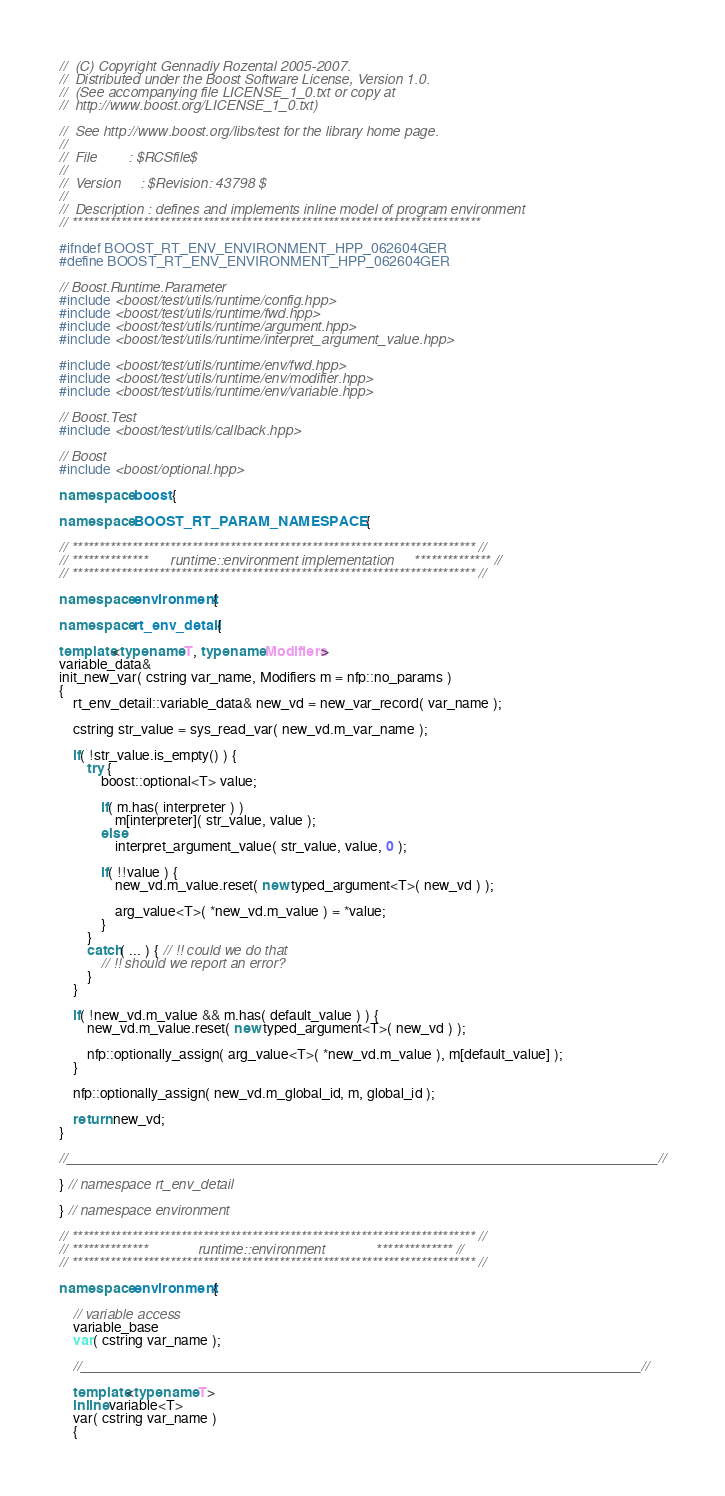<code> <loc_0><loc_0><loc_500><loc_500><_C++_>//  (C) Copyright Gennadiy Rozental 2005-2007.
//  Distributed under the Boost Software License, Version 1.0.
//  (See accompanying file LICENSE_1_0.txt or copy at 
//  http://www.boost.org/LICENSE_1_0.txt)

//  See http://www.boost.org/libs/test for the library home page.
//
//  File        : $RCSfile$
//
//  Version     : $Revision: 43798 $
//
//  Description : defines and implements inline model of program environment 
// ***************************************************************************

#ifndef BOOST_RT_ENV_ENVIRONMENT_HPP_062604GER
#define BOOST_RT_ENV_ENVIRONMENT_HPP_062604GER

// Boost.Runtime.Parameter
#include <boost/test/utils/runtime/config.hpp>
#include <boost/test/utils/runtime/fwd.hpp>
#include <boost/test/utils/runtime/argument.hpp>
#include <boost/test/utils/runtime/interpret_argument_value.hpp>

#include <boost/test/utils/runtime/env/fwd.hpp>
#include <boost/test/utils/runtime/env/modifier.hpp>
#include <boost/test/utils/runtime/env/variable.hpp>

// Boost.Test
#include <boost/test/utils/callback.hpp>

// Boost
#include <boost/optional.hpp>

namespace boost {

namespace BOOST_RT_PARAM_NAMESPACE {

// ************************************************************************** //
// **************      runtime::environment implementation     ************** //
// ************************************************************************** //

namespace environment {

namespace rt_env_detail {

template<typename T, typename Modifiers>
variable_data&
init_new_var( cstring var_name, Modifiers m = nfp::no_params )
{
    rt_env_detail::variable_data& new_vd = new_var_record( var_name );

    cstring str_value = sys_read_var( new_vd.m_var_name );

    if( !str_value.is_empty() ) {
        try {
            boost::optional<T> value;

            if( m.has( interpreter ) )
                m[interpreter]( str_value, value );
            else
                interpret_argument_value( str_value, value, 0 );

            if( !!value ) {
                new_vd.m_value.reset( new typed_argument<T>( new_vd ) );

                arg_value<T>( *new_vd.m_value ) = *value;
            }
        }
        catch( ... ) { // !! could we do that
            // !! should we report an error?
        }
    }

    if( !new_vd.m_value && m.has( default_value ) ) {
        new_vd.m_value.reset( new typed_argument<T>( new_vd ) );

        nfp::optionally_assign( arg_value<T>( *new_vd.m_value ), m[default_value] );
    }

    nfp::optionally_assign( new_vd.m_global_id, m, global_id );

    return new_vd;
}

//____________________________________________________________________________//

} // namespace rt_env_detail

} // namespace environment

// ************************************************************************** //
// **************             runtime::environment             ************** //
// ************************************************************************** //

namespace environment {

    // variable access
    variable_base
    var( cstring var_name );

    //________________________________________________________________________//

    template<typename T>
    inline variable<T>
    var( cstring var_name )
    {</code> 